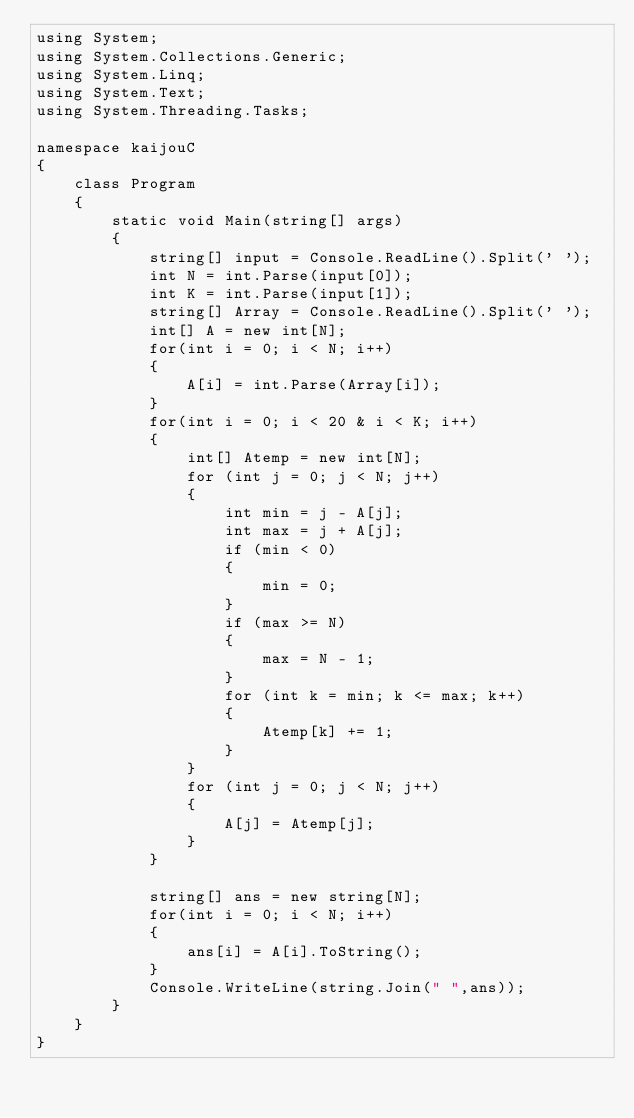<code> <loc_0><loc_0><loc_500><loc_500><_C#_>using System;
using System.Collections.Generic;
using System.Linq;
using System.Text;
using System.Threading.Tasks;

namespace kaijouC
{
    class Program
    {
        static void Main(string[] args)
        {
            string[] input = Console.ReadLine().Split(' ');
            int N = int.Parse(input[0]);
            int K = int.Parse(input[1]);
            string[] Array = Console.ReadLine().Split(' ');
            int[] A = new int[N];
            for(int i = 0; i < N; i++)
            {
                A[i] = int.Parse(Array[i]);
            }
            for(int i = 0; i < 20 & i < K; i++)
            {
                int[] Atemp = new int[N];
                for (int j = 0; j < N; j++)
                {
                    int min = j - A[j];
                    int max = j + A[j];
                    if (min < 0)
                    {
                        min = 0;
                    }
                    if (max >= N)
                    {
                        max = N - 1;
                    }
                    for (int k = min; k <= max; k++)
                    {
                        Atemp[k] += 1;
                    }
                }
                for (int j = 0; j < N; j++)
                {
                    A[j] = Atemp[j];
                }
            }

            string[] ans = new string[N];
            for(int i = 0; i < N; i++)
            {
                ans[i] = A[i].ToString();
            }
            Console.WriteLine(string.Join(" ",ans));
        }
    }
}
</code> 